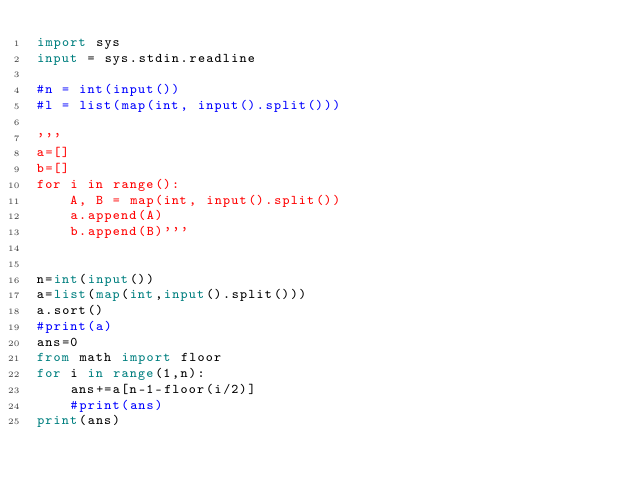<code> <loc_0><loc_0><loc_500><loc_500><_Python_>import sys
input = sys.stdin.readline

#n = int(input())
#l = list(map(int, input().split()))

'''
a=[]
b=[]
for i in range():
    A, B = map(int, input().split())
    a.append(A)   
    b.append(B)'''


n=int(input())
a=list(map(int,input().split()))
a.sort()
#print(a)
ans=0
from math import floor
for i in range(1,n):
    ans+=a[n-1-floor(i/2)]
    #print(ans)
print(ans)
</code> 